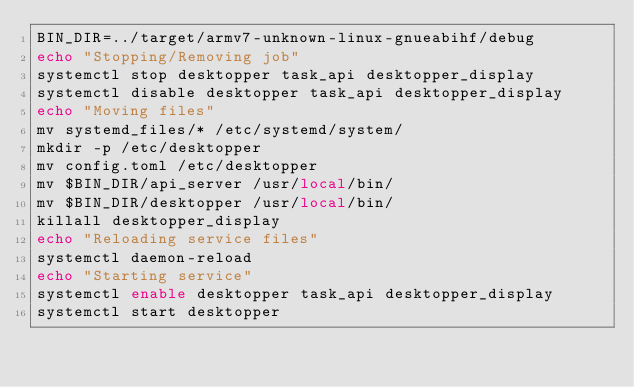<code> <loc_0><loc_0><loc_500><loc_500><_Bash_>BIN_DIR=../target/armv7-unknown-linux-gnueabihf/debug
echo "Stopping/Removing job"
systemctl stop desktopper task_api desktopper_display
systemctl disable desktopper task_api desktopper_display
echo "Moving files"
mv systemd_files/* /etc/systemd/system/
mkdir -p /etc/desktopper
mv config.toml /etc/desktopper
mv $BIN_DIR/api_server /usr/local/bin/
mv $BIN_DIR/desktopper /usr/local/bin/
killall desktopper_display
echo "Reloading service files"
systemctl daemon-reload
echo "Starting service"
systemctl enable desktopper task_api desktopper_display
systemctl start desktopper
</code> 